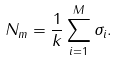Convert formula to latex. <formula><loc_0><loc_0><loc_500><loc_500>N _ { m } = \frac { 1 } { k } \sum _ { i = 1 } ^ { M } \sigma _ { i } .</formula> 